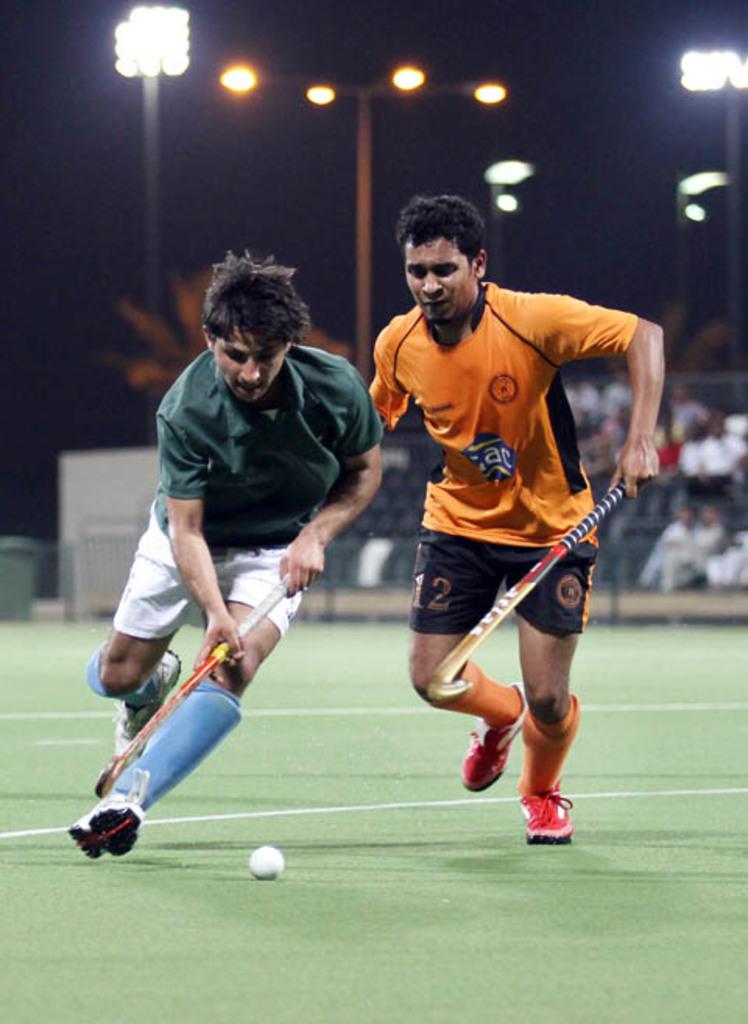What number is the man in orange?
Keep it short and to the point. 12. 